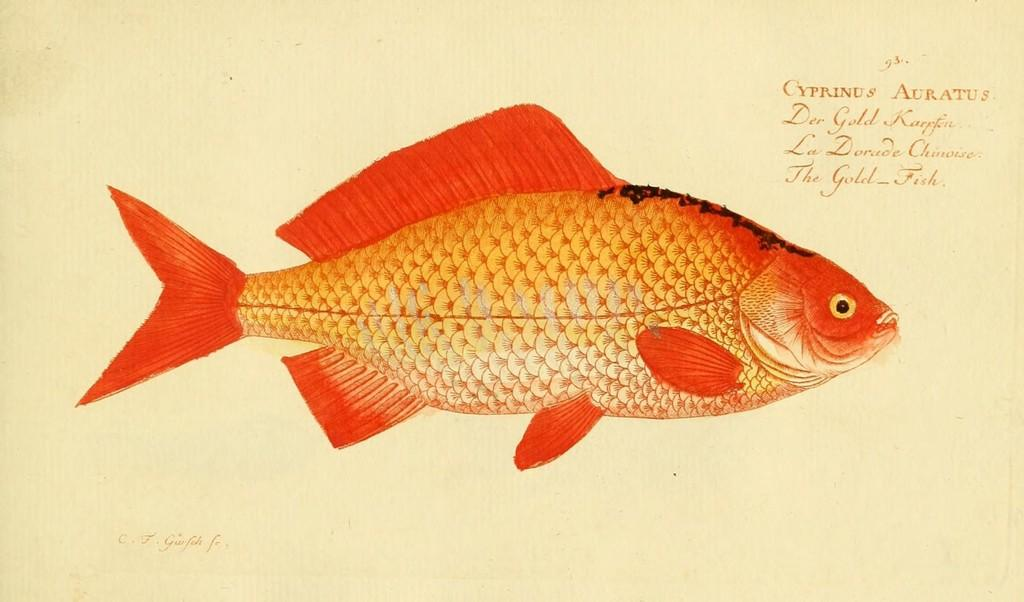What is the main subject of the drawing in the image? The main subject of the drawing in the image is an orange color fish. What else is present in the image besides the drawing? There is text on paper in the image. What type of summer activity is depicted in the image? There is no summer activity depicted in the image; it features a drawing of an orange color fish and text on paper. Are there any giants present in the image? There are no giants present in the image. 